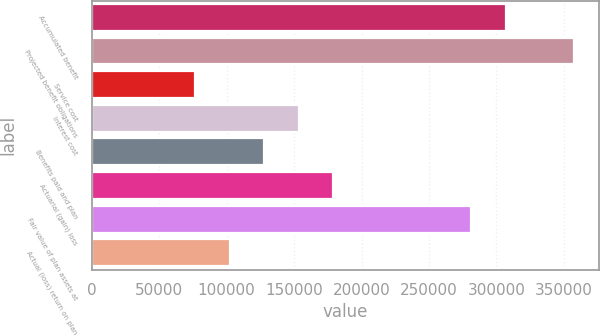Convert chart to OTSL. <chart><loc_0><loc_0><loc_500><loc_500><bar_chart><fcel>Accumulated benefit<fcel>Projected benefit obligations<fcel>Service cost<fcel>Interest cost<fcel>Benefits paid and plan<fcel>Actuarial (gain) loss<fcel>Fair value of plan assets at<fcel>Actual (loss) return on plan<nl><fcel>306717<fcel>357836<fcel>76682<fcel>153360<fcel>127801<fcel>178920<fcel>281157<fcel>102241<nl></chart> 